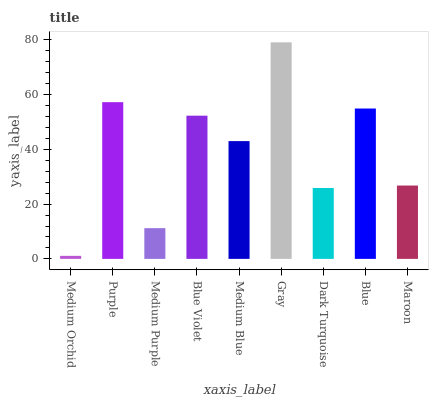Is Medium Orchid the minimum?
Answer yes or no. Yes. Is Gray the maximum?
Answer yes or no. Yes. Is Purple the minimum?
Answer yes or no. No. Is Purple the maximum?
Answer yes or no. No. Is Purple greater than Medium Orchid?
Answer yes or no. Yes. Is Medium Orchid less than Purple?
Answer yes or no. Yes. Is Medium Orchid greater than Purple?
Answer yes or no. No. Is Purple less than Medium Orchid?
Answer yes or no. No. Is Medium Blue the high median?
Answer yes or no. Yes. Is Medium Blue the low median?
Answer yes or no. Yes. Is Medium Purple the high median?
Answer yes or no. No. Is Maroon the low median?
Answer yes or no. No. 